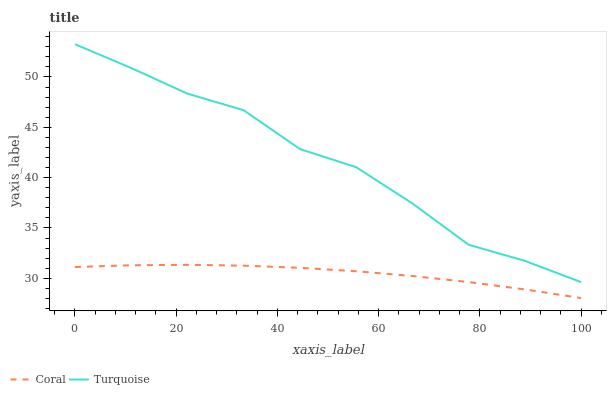Does Coral have the minimum area under the curve?
Answer yes or no. Yes. Does Turquoise have the maximum area under the curve?
Answer yes or no. Yes. Does Turquoise have the minimum area under the curve?
Answer yes or no. No. Is Coral the smoothest?
Answer yes or no. Yes. Is Turquoise the roughest?
Answer yes or no. Yes. Is Turquoise the smoothest?
Answer yes or no. No. Does Coral have the lowest value?
Answer yes or no. Yes. Does Turquoise have the lowest value?
Answer yes or no. No. Does Turquoise have the highest value?
Answer yes or no. Yes. Is Coral less than Turquoise?
Answer yes or no. Yes. Is Turquoise greater than Coral?
Answer yes or no. Yes. Does Coral intersect Turquoise?
Answer yes or no. No. 